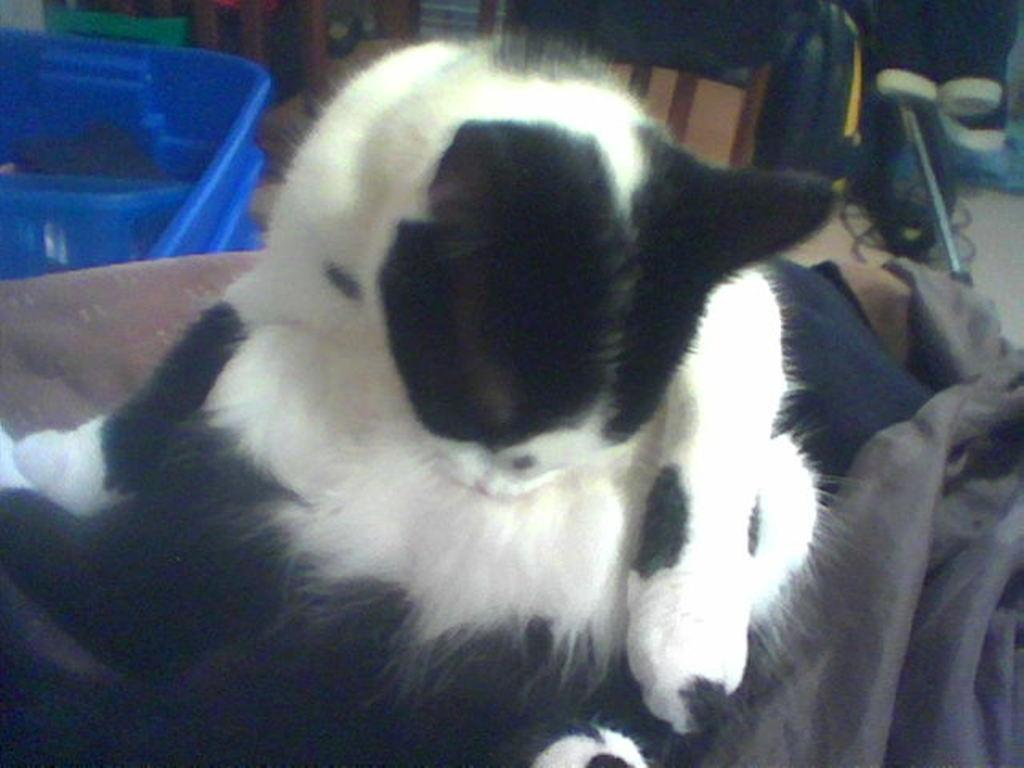What type of animal is in the image? There is a black and white cat in the image. What is the cat interacting with in the image? There is a cloth in the image, which the cat may be interacting with. What color is the object on the left side of the image? There is a blue color object on the left side of the image. What can be seen in the background of the image? There are items visible in the background of the image. How many chickens are present in the image? There are no chickens present in the image; it features a black and white cat, a cloth, and a blue object. What type of pest control is being used in the image? There is no indication of pest control in the image; it simply shows a cat, a cloth, and a blue object. 